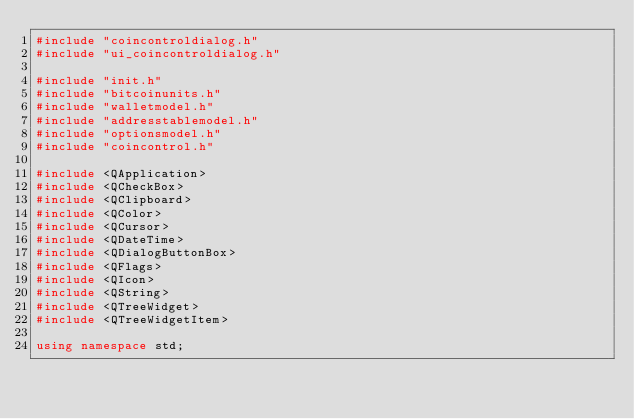<code> <loc_0><loc_0><loc_500><loc_500><_C++_>#include "coincontroldialog.h"
#include "ui_coincontroldialog.h"

#include "init.h"
#include "bitcoinunits.h"
#include "walletmodel.h"
#include "addresstablemodel.h"
#include "optionsmodel.h"
#include "coincontrol.h"

#include <QApplication>
#include <QCheckBox>
#include <QClipboard>
#include <QColor>
#include <QCursor>
#include <QDateTime>
#include <QDialogButtonBox>
#include <QFlags>
#include <QIcon>
#include <QString>
#include <QTreeWidget>
#include <QTreeWidgetItem>

using namespace std;</code> 